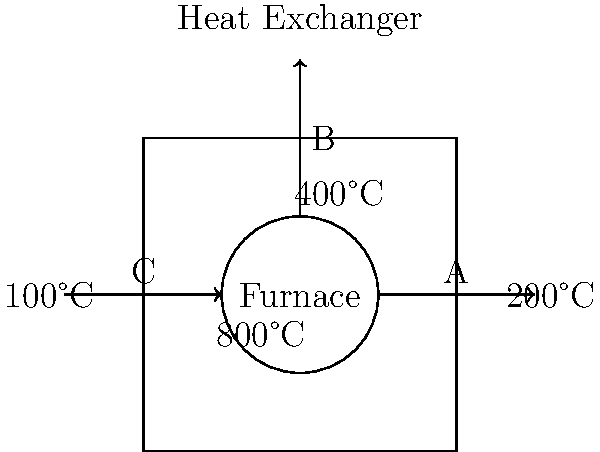In the industrial heat flow diagram shown, which pipe (A, B, or C) represents the coolant inlet based on the temperature gradients and the direction of heat transfer? To determine which pipe represents the coolant inlet, we need to analyze the temperature gradients and heat flow direction:

1. The furnace is the heat source, with the highest temperature of 800°C.

2. Pipe A shows an outflow from the furnace with a temperature of 200°C. This indicates that heat has been transferred from the furnace to this flow, likely heating up the fluid in this pipe.

3. Pipe B shows an upward flow from the furnace to the heat exchanger, with a temperature of 400°C. This is likely a hot fluid being sent to the heat exchanger to transfer heat.

4. Pipe C shows an inflow towards the furnace with a temperature of 100°C. This is the lowest temperature in the system.

5. In a heat exchange system, the coolant is typically the fluid with the lowest temperature, used to absorb heat from the hotter components.

6. The arrow on Pipe C indicates that this low-temperature fluid is flowing into the system, which is characteristic of a coolant inlet.

Therefore, based on the temperature gradient and flow direction, Pipe C represents the coolant inlet to the system.
Answer: C 